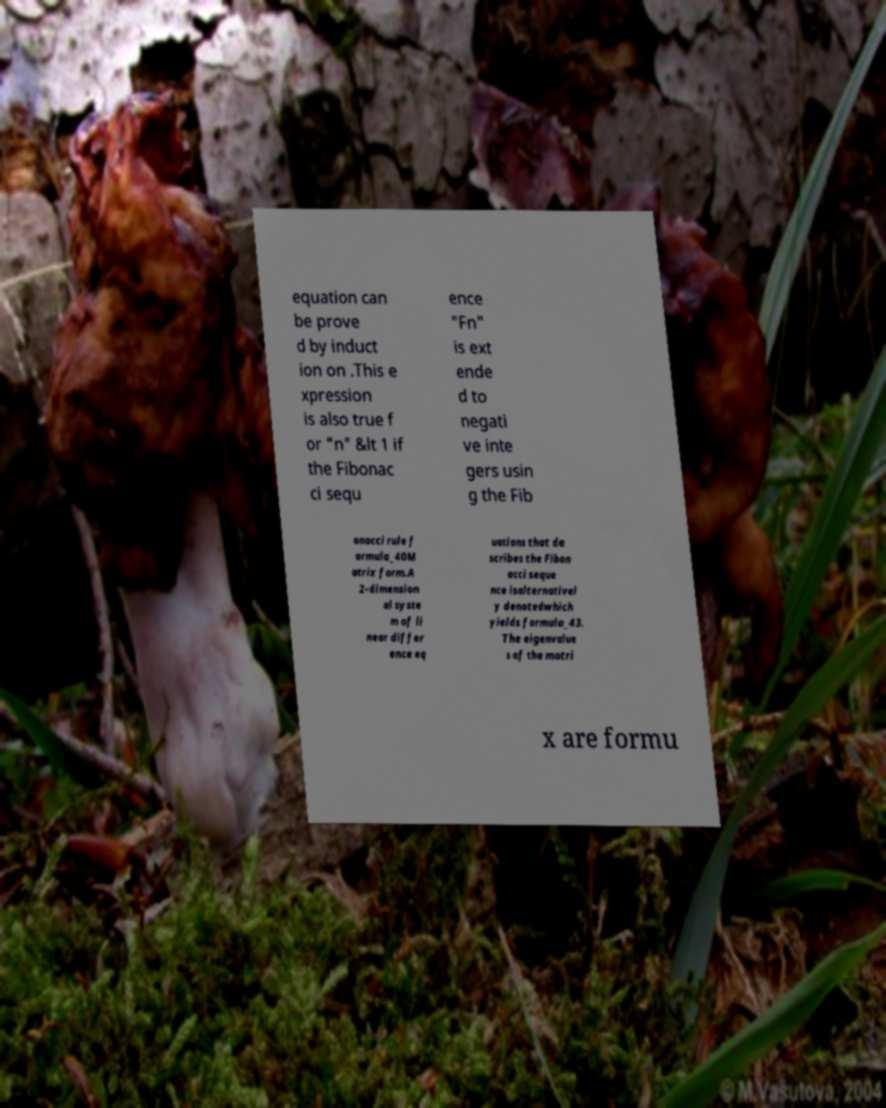What messages or text are displayed in this image? I need them in a readable, typed format. equation can be prove d by induct ion on .This e xpression is also true f or "n" &lt 1 if the Fibonac ci sequ ence "Fn" is ext ende d to negati ve inte gers usin g the Fib onacci rule f ormula_40M atrix form.A 2-dimension al syste m of li near differ ence eq uations that de scribes the Fibon acci seque nce isalternativel y denotedwhich yields formula_43. The eigenvalue s of the matri x are formu 